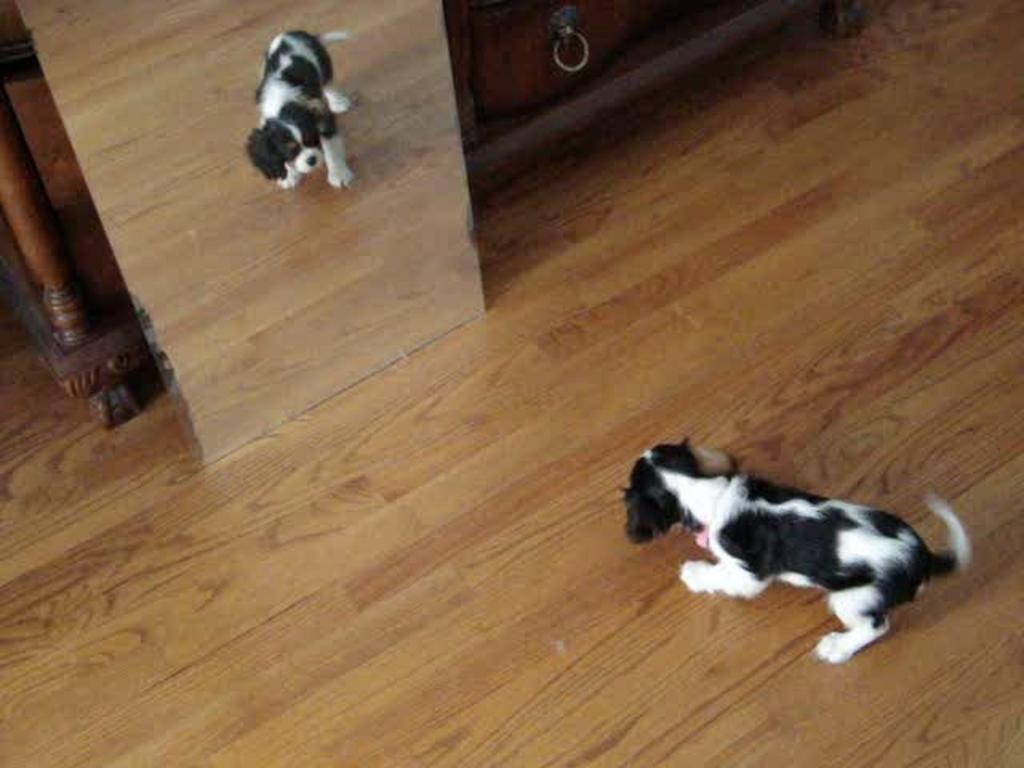Could you give a brief overview of what you see in this image? In this image I can see a dog on the floor and its mirror image in the mirror. In the background I can see a table and a cabinet. This image is taken may be in a hall. 